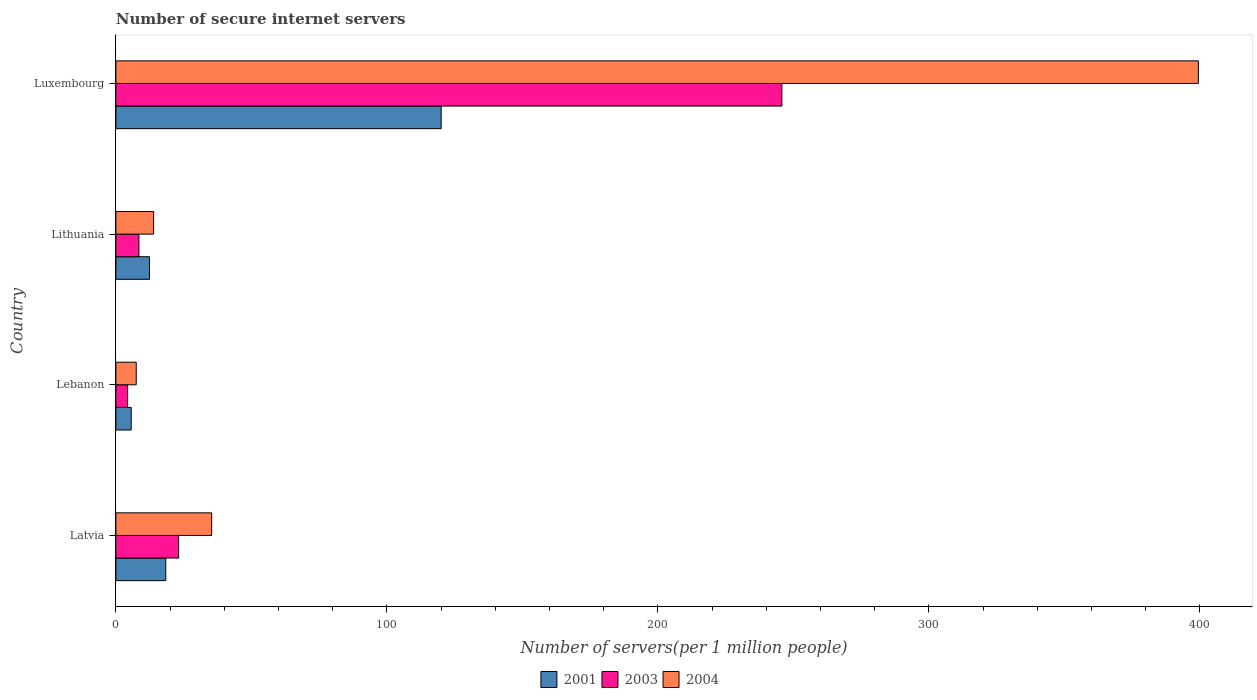How many different coloured bars are there?
Offer a terse response. 3. How many groups of bars are there?
Your answer should be very brief. 4. Are the number of bars per tick equal to the number of legend labels?
Offer a terse response. Yes. Are the number of bars on each tick of the Y-axis equal?
Keep it short and to the point. Yes. What is the label of the 3rd group of bars from the top?
Give a very brief answer. Lebanon. In how many cases, is the number of bars for a given country not equal to the number of legend labels?
Your response must be concise. 0. What is the number of secure internet servers in 2003 in Luxembourg?
Give a very brief answer. 245.78. Across all countries, what is the maximum number of secure internet servers in 2003?
Your response must be concise. 245.78. Across all countries, what is the minimum number of secure internet servers in 2004?
Offer a very short reply. 7.51. In which country was the number of secure internet servers in 2004 maximum?
Your answer should be compact. Luxembourg. In which country was the number of secure internet servers in 2001 minimum?
Offer a very short reply. Lebanon. What is the total number of secure internet servers in 2003 in the graph?
Offer a very short reply. 281.76. What is the difference between the number of secure internet servers in 2004 in Latvia and that in Lithuania?
Offer a very short reply. 21.43. What is the difference between the number of secure internet servers in 2001 in Lithuania and the number of secure internet servers in 2004 in Latvia?
Provide a succinct answer. -22.96. What is the average number of secure internet servers in 2001 per country?
Keep it short and to the point. 39.12. What is the difference between the number of secure internet servers in 2003 and number of secure internet servers in 2004 in Lebanon?
Ensure brevity in your answer.  -3.18. What is the ratio of the number of secure internet servers in 2003 in Latvia to that in Luxembourg?
Give a very brief answer. 0.09. Is the difference between the number of secure internet servers in 2003 in Latvia and Lithuania greater than the difference between the number of secure internet servers in 2004 in Latvia and Lithuania?
Your answer should be compact. No. What is the difference between the highest and the second highest number of secure internet servers in 2001?
Provide a short and direct response. 101.64. What is the difference between the highest and the lowest number of secure internet servers in 2004?
Offer a terse response. 391.97. What does the 3rd bar from the top in Latvia represents?
Provide a succinct answer. 2001. Is it the case that in every country, the sum of the number of secure internet servers in 2004 and number of secure internet servers in 2003 is greater than the number of secure internet servers in 2001?
Give a very brief answer. Yes. How many bars are there?
Offer a terse response. 12. Are all the bars in the graph horizontal?
Your response must be concise. Yes. How many countries are there in the graph?
Your response must be concise. 4. How many legend labels are there?
Provide a short and direct response. 3. How are the legend labels stacked?
Your answer should be very brief. Horizontal. What is the title of the graph?
Give a very brief answer. Number of secure internet servers. Does "2004" appear as one of the legend labels in the graph?
Give a very brief answer. Yes. What is the label or title of the X-axis?
Make the answer very short. Number of servers(per 1 million people). What is the label or title of the Y-axis?
Your answer should be very brief. Country. What is the Number of servers(per 1 million people) of 2001 in Latvia?
Offer a very short reply. 18.4. What is the Number of servers(per 1 million people) in 2003 in Latvia?
Provide a short and direct response. 23.16. What is the Number of servers(per 1 million people) of 2004 in Latvia?
Your answer should be compact. 35.35. What is the Number of servers(per 1 million people) of 2001 in Lebanon?
Provide a succinct answer. 5.65. What is the Number of servers(per 1 million people) of 2003 in Lebanon?
Your answer should be compact. 4.32. What is the Number of servers(per 1 million people) of 2004 in Lebanon?
Your response must be concise. 7.51. What is the Number of servers(per 1 million people) of 2001 in Lithuania?
Keep it short and to the point. 12.39. What is the Number of servers(per 1 million people) in 2003 in Lithuania?
Your answer should be very brief. 8.49. What is the Number of servers(per 1 million people) of 2004 in Lithuania?
Offer a terse response. 13.92. What is the Number of servers(per 1 million people) of 2001 in Luxembourg?
Provide a succinct answer. 120.04. What is the Number of servers(per 1 million people) in 2003 in Luxembourg?
Provide a succinct answer. 245.78. What is the Number of servers(per 1 million people) of 2004 in Luxembourg?
Offer a very short reply. 399.48. Across all countries, what is the maximum Number of servers(per 1 million people) of 2001?
Give a very brief answer. 120.04. Across all countries, what is the maximum Number of servers(per 1 million people) in 2003?
Make the answer very short. 245.78. Across all countries, what is the maximum Number of servers(per 1 million people) in 2004?
Your answer should be compact. 399.48. Across all countries, what is the minimum Number of servers(per 1 million people) of 2001?
Give a very brief answer. 5.65. Across all countries, what is the minimum Number of servers(per 1 million people) in 2003?
Your answer should be very brief. 4.32. Across all countries, what is the minimum Number of servers(per 1 million people) in 2004?
Provide a short and direct response. 7.51. What is the total Number of servers(per 1 million people) in 2001 in the graph?
Provide a succinct answer. 156.48. What is the total Number of servers(per 1 million people) in 2003 in the graph?
Provide a succinct answer. 281.76. What is the total Number of servers(per 1 million people) in 2004 in the graph?
Keep it short and to the point. 456.25. What is the difference between the Number of servers(per 1 million people) of 2001 in Latvia and that in Lebanon?
Offer a very short reply. 12.74. What is the difference between the Number of servers(per 1 million people) in 2003 in Latvia and that in Lebanon?
Give a very brief answer. 18.84. What is the difference between the Number of servers(per 1 million people) of 2004 in Latvia and that in Lebanon?
Make the answer very short. 27.84. What is the difference between the Number of servers(per 1 million people) of 2001 in Latvia and that in Lithuania?
Offer a very short reply. 6.01. What is the difference between the Number of servers(per 1 million people) of 2003 in Latvia and that in Lithuania?
Offer a very short reply. 14.67. What is the difference between the Number of servers(per 1 million people) in 2004 in Latvia and that in Lithuania?
Your response must be concise. 21.43. What is the difference between the Number of servers(per 1 million people) in 2001 in Latvia and that in Luxembourg?
Offer a very short reply. -101.64. What is the difference between the Number of servers(per 1 million people) of 2003 in Latvia and that in Luxembourg?
Give a very brief answer. -222.61. What is the difference between the Number of servers(per 1 million people) in 2004 in Latvia and that in Luxembourg?
Offer a very short reply. -364.13. What is the difference between the Number of servers(per 1 million people) in 2001 in Lebanon and that in Lithuania?
Offer a terse response. -6.73. What is the difference between the Number of servers(per 1 million people) in 2003 in Lebanon and that in Lithuania?
Your response must be concise. -4.17. What is the difference between the Number of servers(per 1 million people) of 2004 in Lebanon and that in Lithuania?
Your answer should be compact. -6.41. What is the difference between the Number of servers(per 1 million people) in 2001 in Lebanon and that in Luxembourg?
Keep it short and to the point. -114.38. What is the difference between the Number of servers(per 1 million people) in 2003 in Lebanon and that in Luxembourg?
Your response must be concise. -241.45. What is the difference between the Number of servers(per 1 million people) of 2004 in Lebanon and that in Luxembourg?
Ensure brevity in your answer.  -391.97. What is the difference between the Number of servers(per 1 million people) of 2001 in Lithuania and that in Luxembourg?
Your response must be concise. -107.65. What is the difference between the Number of servers(per 1 million people) of 2003 in Lithuania and that in Luxembourg?
Provide a short and direct response. -237.28. What is the difference between the Number of servers(per 1 million people) in 2004 in Lithuania and that in Luxembourg?
Keep it short and to the point. -385.56. What is the difference between the Number of servers(per 1 million people) of 2001 in Latvia and the Number of servers(per 1 million people) of 2003 in Lebanon?
Offer a terse response. 14.08. What is the difference between the Number of servers(per 1 million people) in 2001 in Latvia and the Number of servers(per 1 million people) in 2004 in Lebanon?
Offer a terse response. 10.89. What is the difference between the Number of servers(per 1 million people) in 2003 in Latvia and the Number of servers(per 1 million people) in 2004 in Lebanon?
Ensure brevity in your answer.  15.66. What is the difference between the Number of servers(per 1 million people) in 2001 in Latvia and the Number of servers(per 1 million people) in 2003 in Lithuania?
Offer a very short reply. 9.91. What is the difference between the Number of servers(per 1 million people) in 2001 in Latvia and the Number of servers(per 1 million people) in 2004 in Lithuania?
Offer a terse response. 4.48. What is the difference between the Number of servers(per 1 million people) of 2003 in Latvia and the Number of servers(per 1 million people) of 2004 in Lithuania?
Offer a terse response. 9.25. What is the difference between the Number of servers(per 1 million people) of 2001 in Latvia and the Number of servers(per 1 million people) of 2003 in Luxembourg?
Your answer should be compact. -227.38. What is the difference between the Number of servers(per 1 million people) in 2001 in Latvia and the Number of servers(per 1 million people) in 2004 in Luxembourg?
Offer a very short reply. -381.08. What is the difference between the Number of servers(per 1 million people) of 2003 in Latvia and the Number of servers(per 1 million people) of 2004 in Luxembourg?
Your answer should be compact. -376.32. What is the difference between the Number of servers(per 1 million people) of 2001 in Lebanon and the Number of servers(per 1 million people) of 2003 in Lithuania?
Your response must be concise. -2.84. What is the difference between the Number of servers(per 1 million people) in 2001 in Lebanon and the Number of servers(per 1 million people) in 2004 in Lithuania?
Ensure brevity in your answer.  -8.26. What is the difference between the Number of servers(per 1 million people) in 2003 in Lebanon and the Number of servers(per 1 million people) in 2004 in Lithuania?
Your response must be concise. -9.59. What is the difference between the Number of servers(per 1 million people) of 2001 in Lebanon and the Number of servers(per 1 million people) of 2003 in Luxembourg?
Provide a short and direct response. -240.12. What is the difference between the Number of servers(per 1 million people) in 2001 in Lebanon and the Number of servers(per 1 million people) in 2004 in Luxembourg?
Ensure brevity in your answer.  -393.83. What is the difference between the Number of servers(per 1 million people) in 2003 in Lebanon and the Number of servers(per 1 million people) in 2004 in Luxembourg?
Give a very brief answer. -395.16. What is the difference between the Number of servers(per 1 million people) of 2001 in Lithuania and the Number of servers(per 1 million people) of 2003 in Luxembourg?
Offer a terse response. -233.39. What is the difference between the Number of servers(per 1 million people) of 2001 in Lithuania and the Number of servers(per 1 million people) of 2004 in Luxembourg?
Make the answer very short. -387.09. What is the difference between the Number of servers(per 1 million people) in 2003 in Lithuania and the Number of servers(per 1 million people) in 2004 in Luxembourg?
Your answer should be compact. -390.99. What is the average Number of servers(per 1 million people) in 2001 per country?
Make the answer very short. 39.12. What is the average Number of servers(per 1 million people) in 2003 per country?
Make the answer very short. 70.44. What is the average Number of servers(per 1 million people) in 2004 per country?
Your answer should be compact. 114.06. What is the difference between the Number of servers(per 1 million people) of 2001 and Number of servers(per 1 million people) of 2003 in Latvia?
Provide a succinct answer. -4.77. What is the difference between the Number of servers(per 1 million people) of 2001 and Number of servers(per 1 million people) of 2004 in Latvia?
Provide a succinct answer. -16.95. What is the difference between the Number of servers(per 1 million people) of 2003 and Number of servers(per 1 million people) of 2004 in Latvia?
Give a very brief answer. -12.18. What is the difference between the Number of servers(per 1 million people) in 2001 and Number of servers(per 1 million people) in 2003 in Lebanon?
Keep it short and to the point. 1.33. What is the difference between the Number of servers(per 1 million people) of 2001 and Number of servers(per 1 million people) of 2004 in Lebanon?
Your response must be concise. -1.85. What is the difference between the Number of servers(per 1 million people) in 2003 and Number of servers(per 1 million people) in 2004 in Lebanon?
Make the answer very short. -3.18. What is the difference between the Number of servers(per 1 million people) in 2001 and Number of servers(per 1 million people) in 2003 in Lithuania?
Your answer should be very brief. 3.9. What is the difference between the Number of servers(per 1 million people) of 2001 and Number of servers(per 1 million people) of 2004 in Lithuania?
Give a very brief answer. -1.53. What is the difference between the Number of servers(per 1 million people) in 2003 and Number of servers(per 1 million people) in 2004 in Lithuania?
Make the answer very short. -5.43. What is the difference between the Number of servers(per 1 million people) in 2001 and Number of servers(per 1 million people) in 2003 in Luxembourg?
Your answer should be very brief. -125.74. What is the difference between the Number of servers(per 1 million people) in 2001 and Number of servers(per 1 million people) in 2004 in Luxembourg?
Your answer should be very brief. -279.44. What is the difference between the Number of servers(per 1 million people) in 2003 and Number of servers(per 1 million people) in 2004 in Luxembourg?
Your answer should be compact. -153.7. What is the ratio of the Number of servers(per 1 million people) of 2001 in Latvia to that in Lebanon?
Offer a terse response. 3.25. What is the ratio of the Number of servers(per 1 million people) in 2003 in Latvia to that in Lebanon?
Offer a very short reply. 5.36. What is the ratio of the Number of servers(per 1 million people) of 2004 in Latvia to that in Lebanon?
Your answer should be very brief. 4.71. What is the ratio of the Number of servers(per 1 million people) in 2001 in Latvia to that in Lithuania?
Your answer should be very brief. 1.49. What is the ratio of the Number of servers(per 1 million people) in 2003 in Latvia to that in Lithuania?
Make the answer very short. 2.73. What is the ratio of the Number of servers(per 1 million people) of 2004 in Latvia to that in Lithuania?
Your answer should be very brief. 2.54. What is the ratio of the Number of servers(per 1 million people) of 2001 in Latvia to that in Luxembourg?
Offer a terse response. 0.15. What is the ratio of the Number of servers(per 1 million people) of 2003 in Latvia to that in Luxembourg?
Your answer should be compact. 0.09. What is the ratio of the Number of servers(per 1 million people) in 2004 in Latvia to that in Luxembourg?
Offer a terse response. 0.09. What is the ratio of the Number of servers(per 1 million people) in 2001 in Lebanon to that in Lithuania?
Your answer should be compact. 0.46. What is the ratio of the Number of servers(per 1 million people) of 2003 in Lebanon to that in Lithuania?
Provide a short and direct response. 0.51. What is the ratio of the Number of servers(per 1 million people) in 2004 in Lebanon to that in Lithuania?
Your response must be concise. 0.54. What is the ratio of the Number of servers(per 1 million people) of 2001 in Lebanon to that in Luxembourg?
Give a very brief answer. 0.05. What is the ratio of the Number of servers(per 1 million people) in 2003 in Lebanon to that in Luxembourg?
Offer a very short reply. 0.02. What is the ratio of the Number of servers(per 1 million people) in 2004 in Lebanon to that in Luxembourg?
Provide a short and direct response. 0.02. What is the ratio of the Number of servers(per 1 million people) of 2001 in Lithuania to that in Luxembourg?
Your answer should be very brief. 0.1. What is the ratio of the Number of servers(per 1 million people) in 2003 in Lithuania to that in Luxembourg?
Provide a short and direct response. 0.03. What is the ratio of the Number of servers(per 1 million people) of 2004 in Lithuania to that in Luxembourg?
Provide a short and direct response. 0.03. What is the difference between the highest and the second highest Number of servers(per 1 million people) of 2001?
Provide a short and direct response. 101.64. What is the difference between the highest and the second highest Number of servers(per 1 million people) in 2003?
Offer a terse response. 222.61. What is the difference between the highest and the second highest Number of servers(per 1 million people) of 2004?
Provide a succinct answer. 364.13. What is the difference between the highest and the lowest Number of servers(per 1 million people) in 2001?
Give a very brief answer. 114.38. What is the difference between the highest and the lowest Number of servers(per 1 million people) of 2003?
Make the answer very short. 241.45. What is the difference between the highest and the lowest Number of servers(per 1 million people) of 2004?
Offer a terse response. 391.97. 